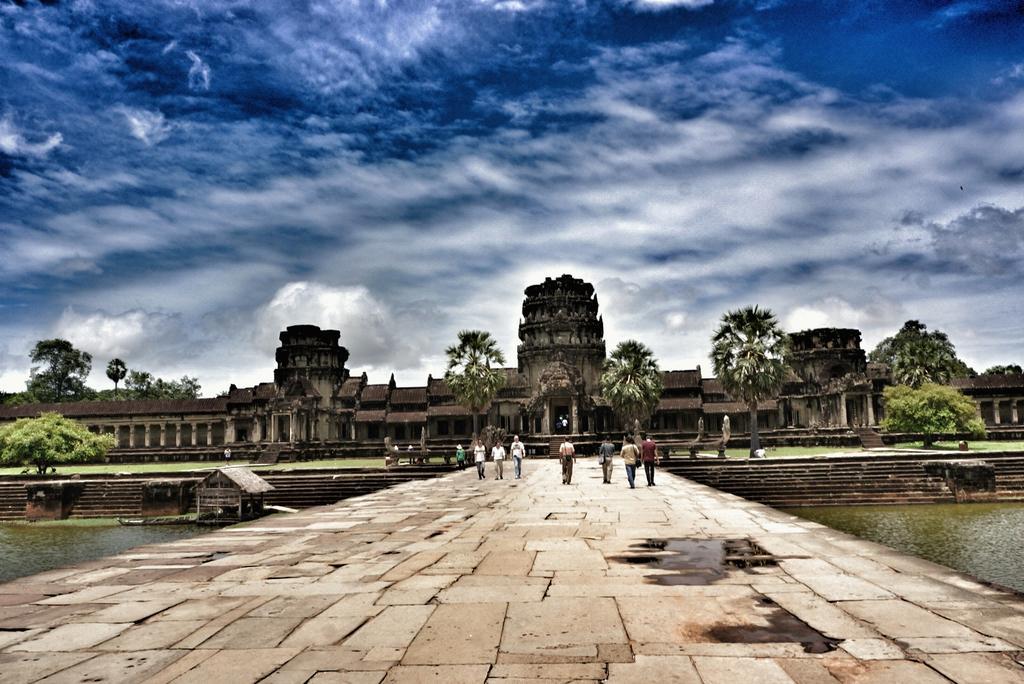Describe this image in one or two sentences. In this image we can see a building and house and there are stairs in front of the building. And there are people walking on the ground and we can see the water, trees, grass and cloudy sky in the background. 